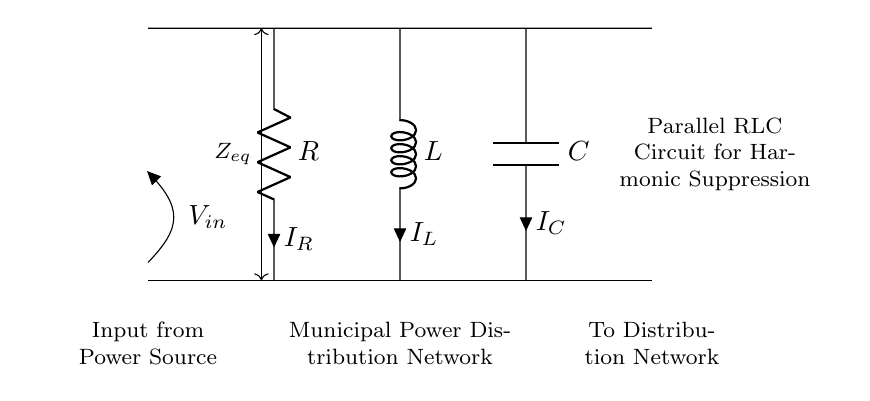What are the components in the circuit? The circuit contains a resistor, an inductor, and a capacitor, which are labeled in the diagram.
Answer: Resistor, Inductor, Capacitor What is the function of RLC circuits in this context? RLC circuits are used for harmonic suppression to improve power quality in municipal distribution networks.
Answer: Harmonic suppression What is the voltage source labeled in the diagram? The voltage source providing input to the circuit is labeled as V sub in, representing the input voltage.
Answer: V in What is the equivalent impedance of this circuit called? The equivalent impedance of the parallel components is denoted as Z sub eq, indicating the combined effect of the resistor, inductor, and capacitor.
Answer: Z eq How does this circuit configuration affect the power distribution network? The parallel arrangement allows for adjustment of impedance, selectively filtering harmonics and maintaining stability in the power system.
Answer: Filtering harmonics What is the direction of current through the resistor? The current through the resistor is labeled as I sub R and flows vertically downward from the node to the bottom of the circuit.
Answer: I R What role does the capacitor play in this circuit? The capacitor helps to provide a path for high-frequency harmonic currents, preventing them from affecting the main power distribution.
Answer: High-frequency filtering 